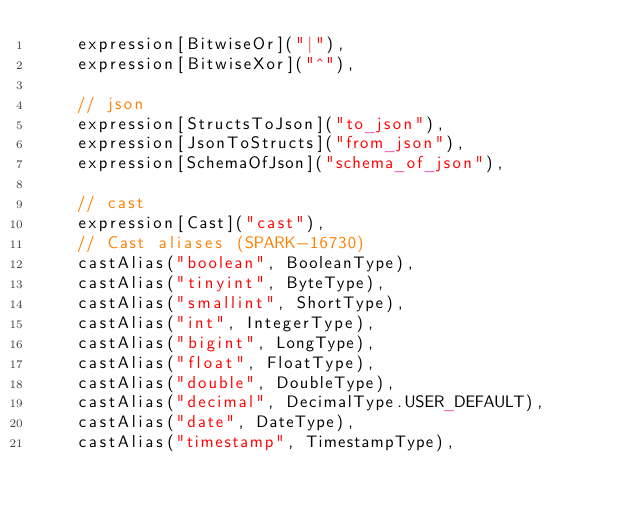Convert code to text. <code><loc_0><loc_0><loc_500><loc_500><_Scala_>    expression[BitwiseOr]("|"),
    expression[BitwiseXor]("^"),

    // json
    expression[StructsToJson]("to_json"),
    expression[JsonToStructs]("from_json"),
    expression[SchemaOfJson]("schema_of_json"),

    // cast
    expression[Cast]("cast"),
    // Cast aliases (SPARK-16730)
    castAlias("boolean", BooleanType),
    castAlias("tinyint", ByteType),
    castAlias("smallint", ShortType),
    castAlias("int", IntegerType),
    castAlias("bigint", LongType),
    castAlias("float", FloatType),
    castAlias("double", DoubleType),
    castAlias("decimal", DecimalType.USER_DEFAULT),
    castAlias("date", DateType),
    castAlias("timestamp", TimestampType),</code> 